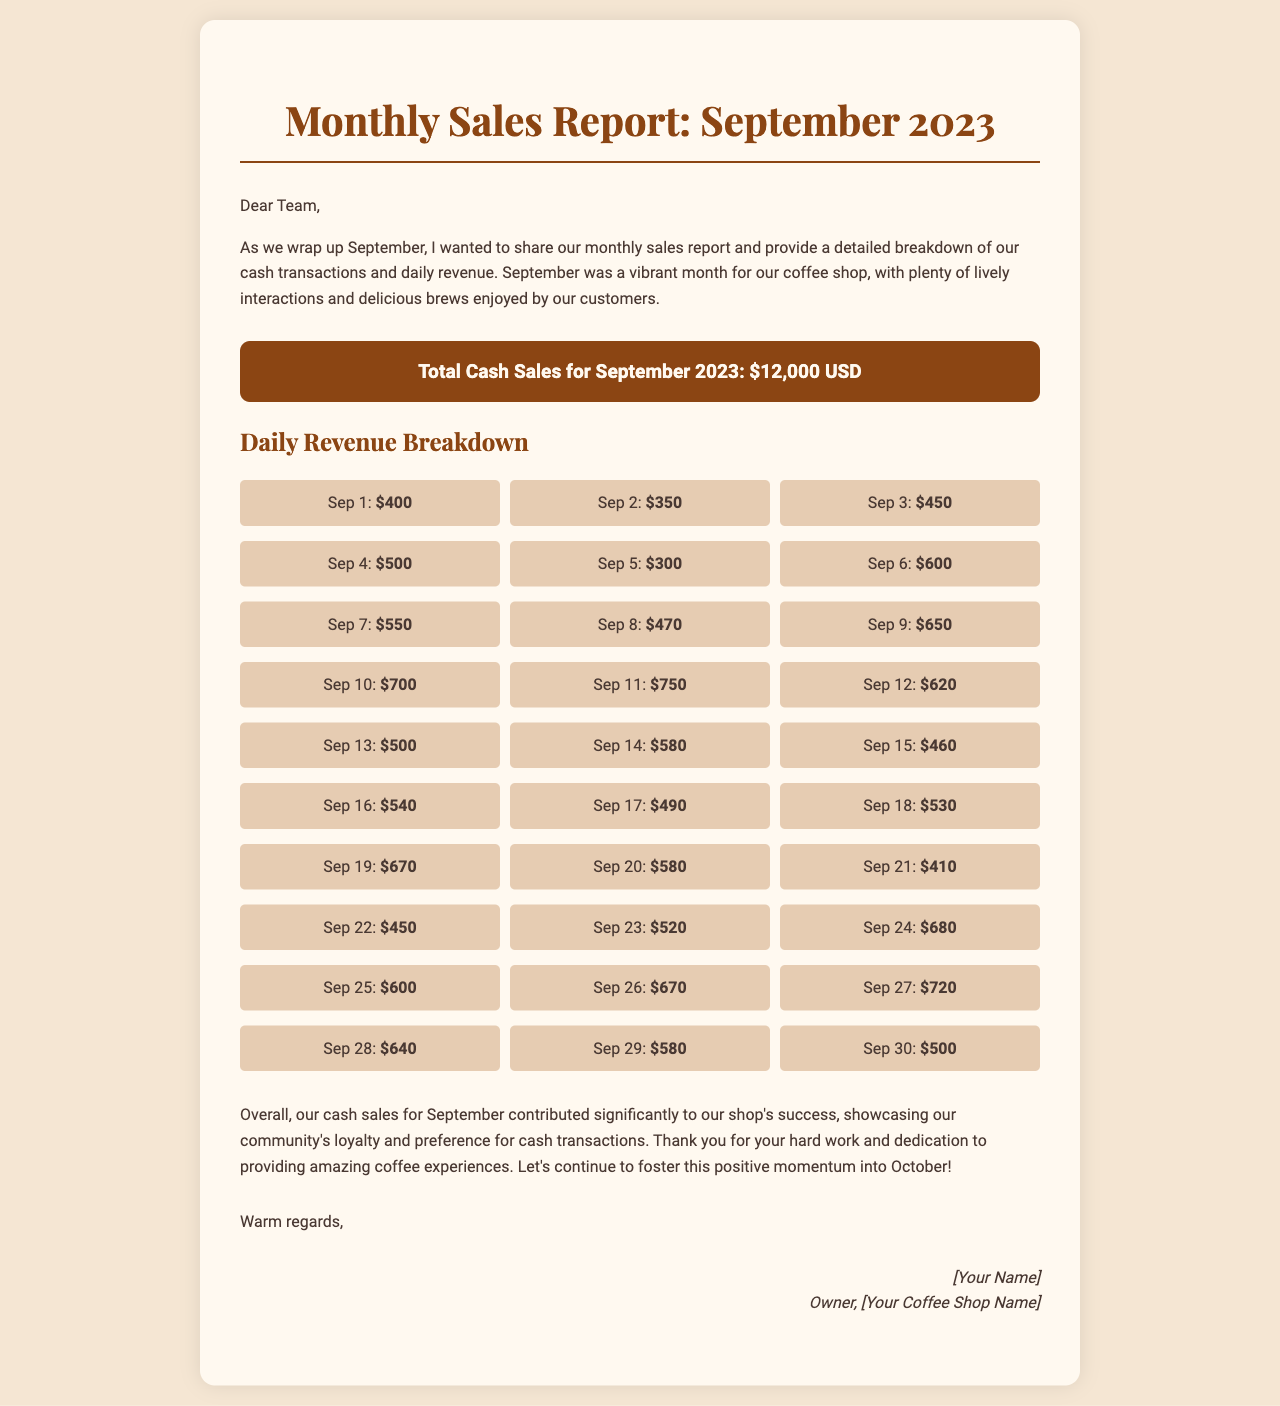what was the total cash sales for September 2023? The total cash sales are stated in the document as $12,000 USD.
Answer: $12,000 USD which day had the highest sales? By looking at the daily revenue breakdown, Sep 10 shows the highest sales amount of $700.
Answer: Sep 10 how many days had sales over $600? By reviewing the daily sales figures, there are 9 days with sales over $600.
Answer: 9 what was the sales amount on Sep 15? The document lists the sales amount for Sep 15 as $460.
Answer: $460 what is the monthly revenue trend indicated in the document? The overall trend suggests increased cash sales throughout the month, showing a positive growth in customer loyalty and preference for cash transactions.
Answer: positive growth who wrote the report? The signature section indicates that it was written by the owner of the coffee shop, identified as [Your Name].
Answer: [Your Name] what is the last date mentioned in the daily revenue breakdown? The daily revenue breakdown ends with Sep 30, which is the last date mentioned.
Answer: Sep 30 how did the owner express gratitude in the report? The owner expressed gratitude by thanking the team for their hard work and dedication to providing amazing coffee experiences.
Answer: thanking the team which style is used for headings in the document? The document states that the 'Playfair Display' font is used for headings and subheadings.
Answer: Playfair Display 